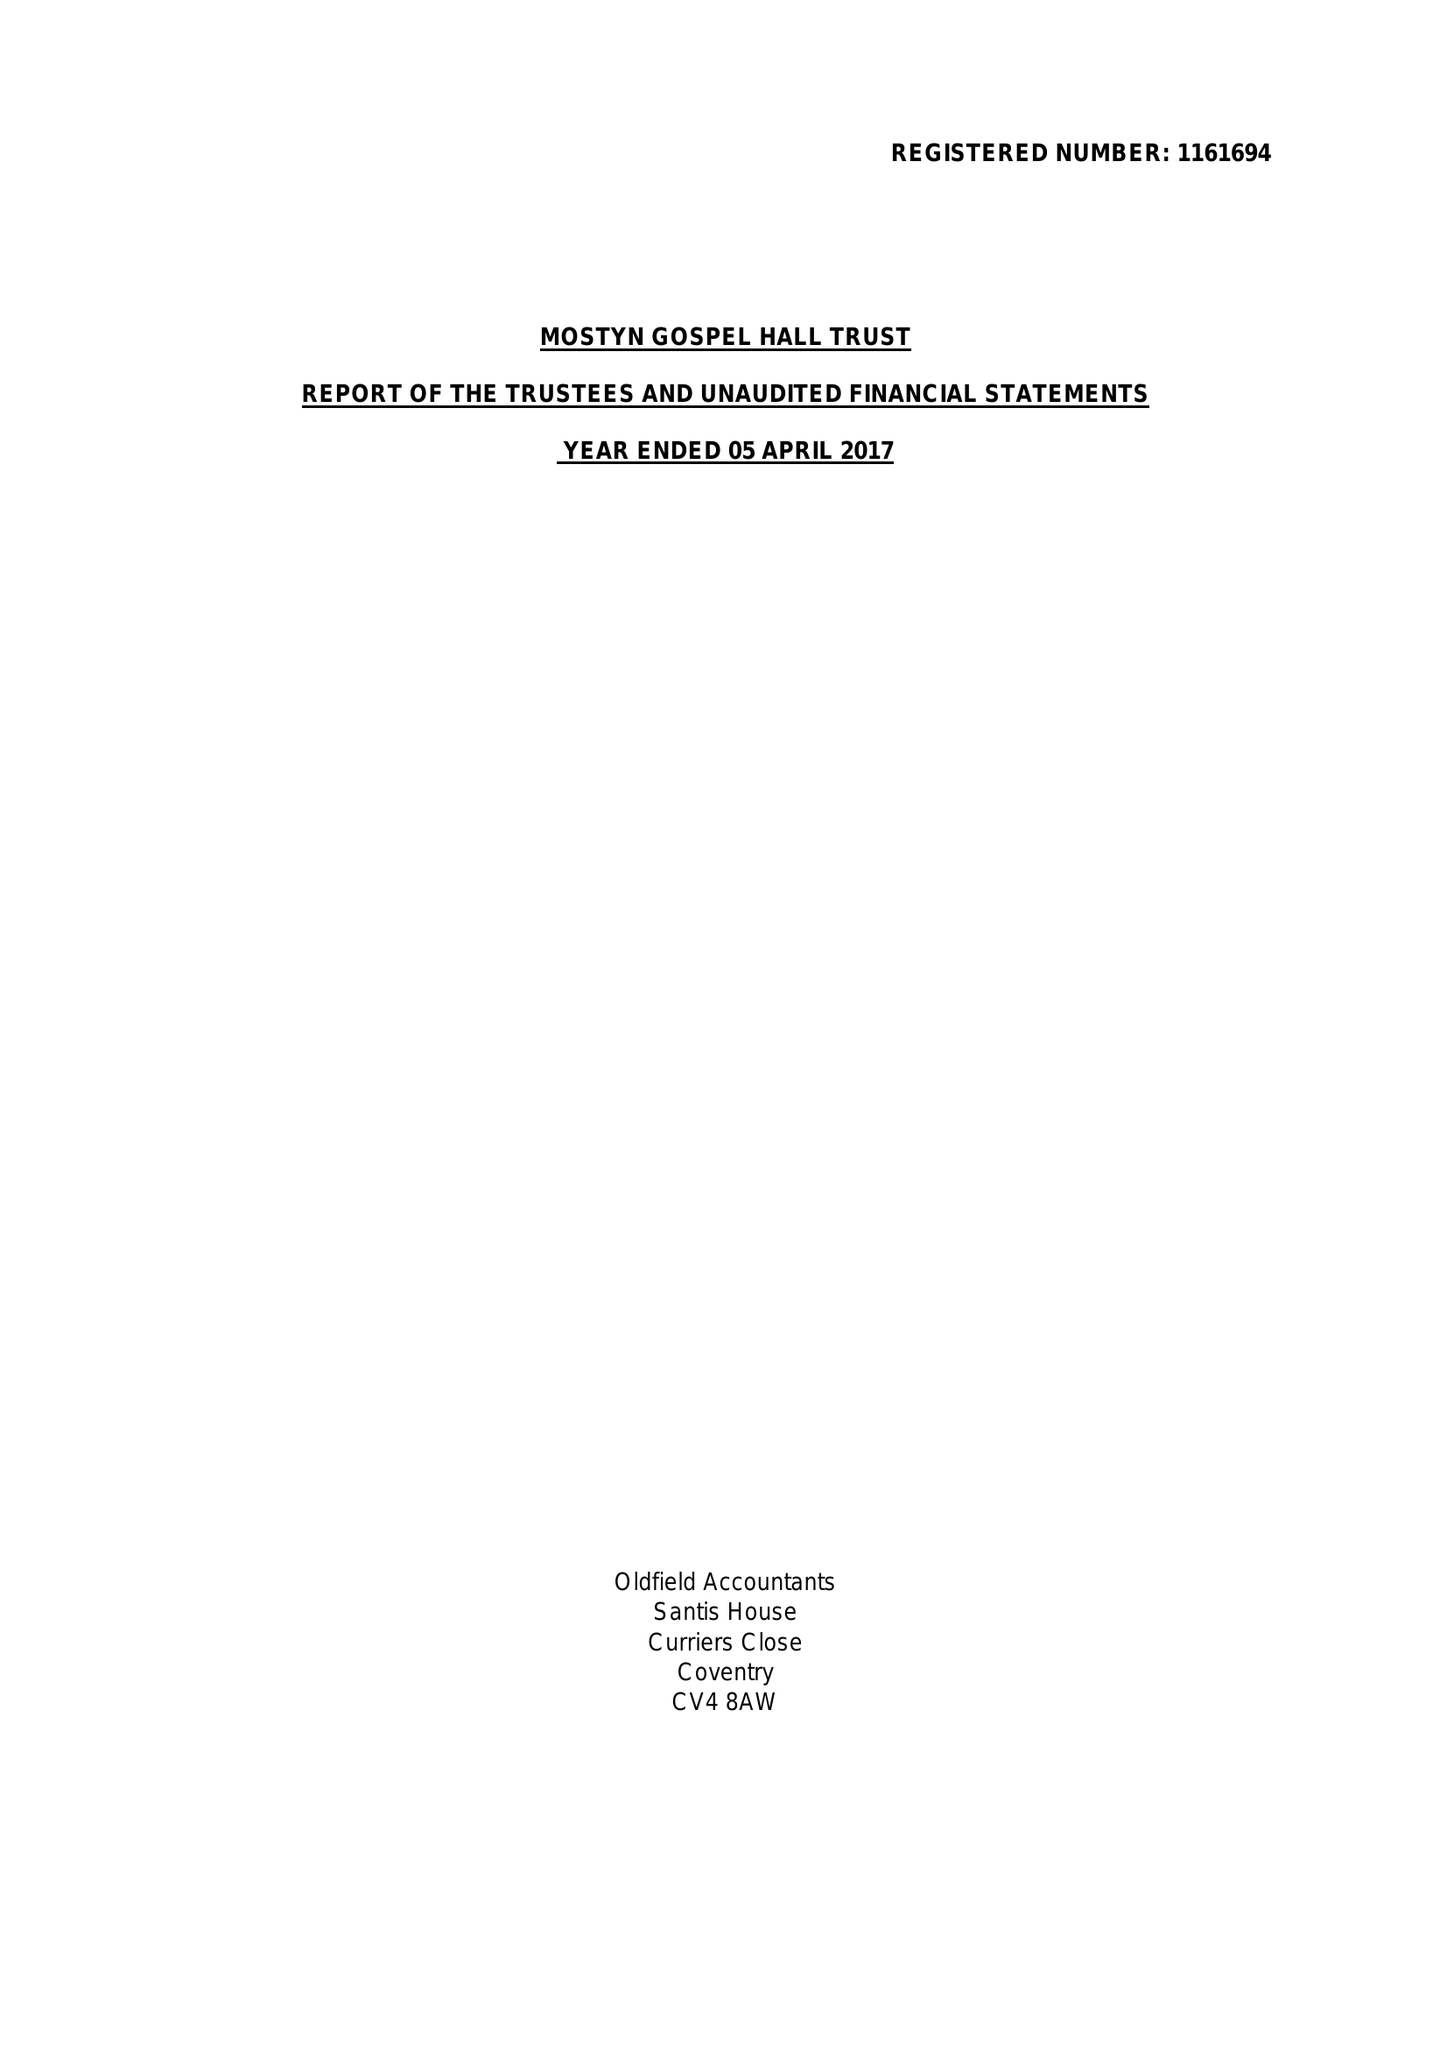What is the value for the charity_number?
Answer the question using a single word or phrase. 1161694 